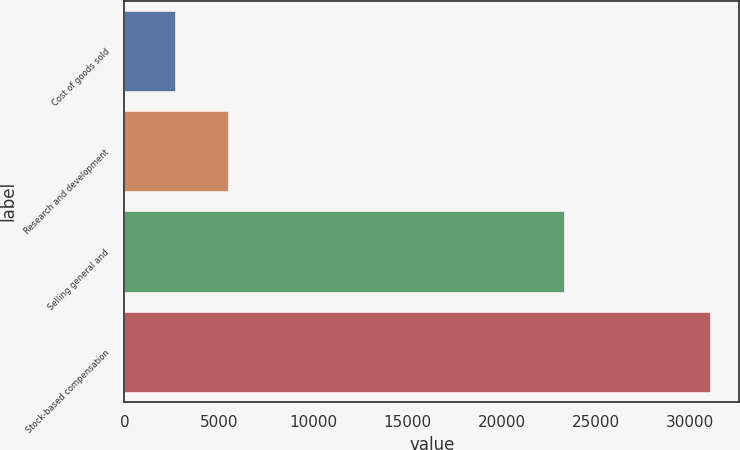<chart> <loc_0><loc_0><loc_500><loc_500><bar_chart><fcel>Cost of goods sold<fcel>Research and development<fcel>Selling general and<fcel>Stock-based compensation<nl><fcel>2665<fcel>5500.3<fcel>23285<fcel>31018<nl></chart> 